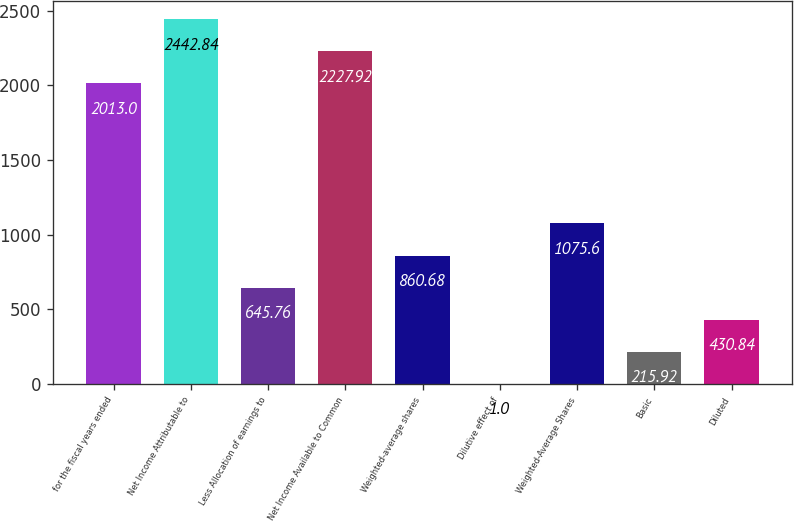Convert chart to OTSL. <chart><loc_0><loc_0><loc_500><loc_500><bar_chart><fcel>for the fiscal years ended<fcel>Net Income Attributable to<fcel>Less Allocation of earnings to<fcel>Net Income Available to Common<fcel>Weighted-average shares<fcel>Dilutive effect of<fcel>Weighted-Average Shares<fcel>Basic<fcel>Diluted<nl><fcel>2013<fcel>2442.84<fcel>645.76<fcel>2227.92<fcel>860.68<fcel>1<fcel>1075.6<fcel>215.92<fcel>430.84<nl></chart> 